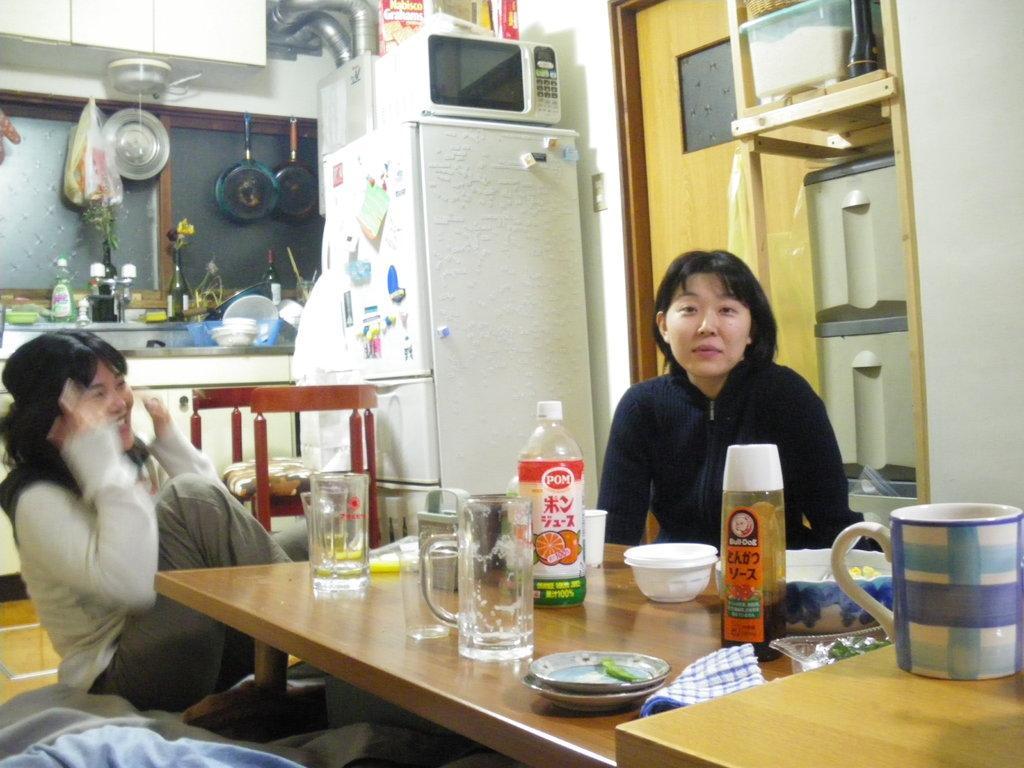Could you give a brief overview of what you see in this image? In this Picture we can see inner view of the kitchen in which two woman are sitting on the chair, In front we have dining table on which sauce bottle, cup, saucer and glasses. Behind we can see the television and oven on it, Beside we be kitchen top with pan hanging and stove. On the top we have door cabinet and insulated pipes. 